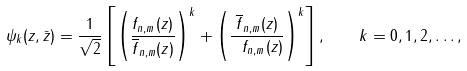Convert formula to latex. <formula><loc_0><loc_0><loc_500><loc_500>\psi _ { k } ( z , \bar { z } ) = { \frac { 1 } { \sqrt { 2 } } } \left [ \left ( { \frac { f _ { n , m } ( z ) } { \overline { f } _ { n , m } ( z ) } } \right ) ^ { k } + \left ( { \frac { \overline { f } _ { n , m } ( z ) } { \ f _ { n , m } ( z ) } } \right ) ^ { k } \right ] , \quad k = 0 , 1 , 2 , \dots ,</formula> 